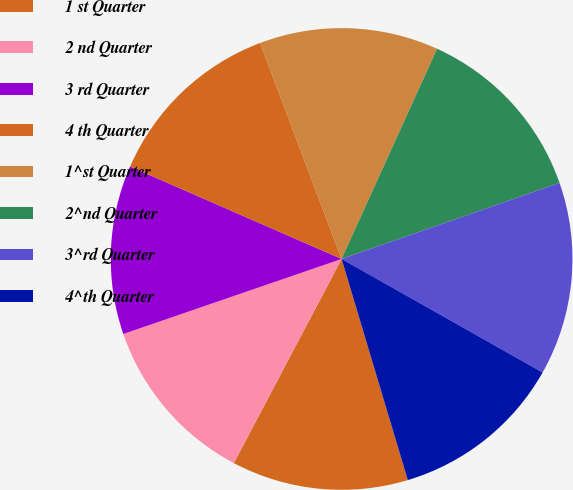<chart> <loc_0><loc_0><loc_500><loc_500><pie_chart><fcel>1 st Quarter<fcel>2 nd Quarter<fcel>3 rd Quarter<fcel>4 th Quarter<fcel>1^st Quarter<fcel>2^nd Quarter<fcel>3^rd Quarter<fcel>4^th Quarter<nl><fcel>12.36%<fcel>12.0%<fcel>11.83%<fcel>12.7%<fcel>12.53%<fcel>12.87%<fcel>13.53%<fcel>12.19%<nl></chart> 